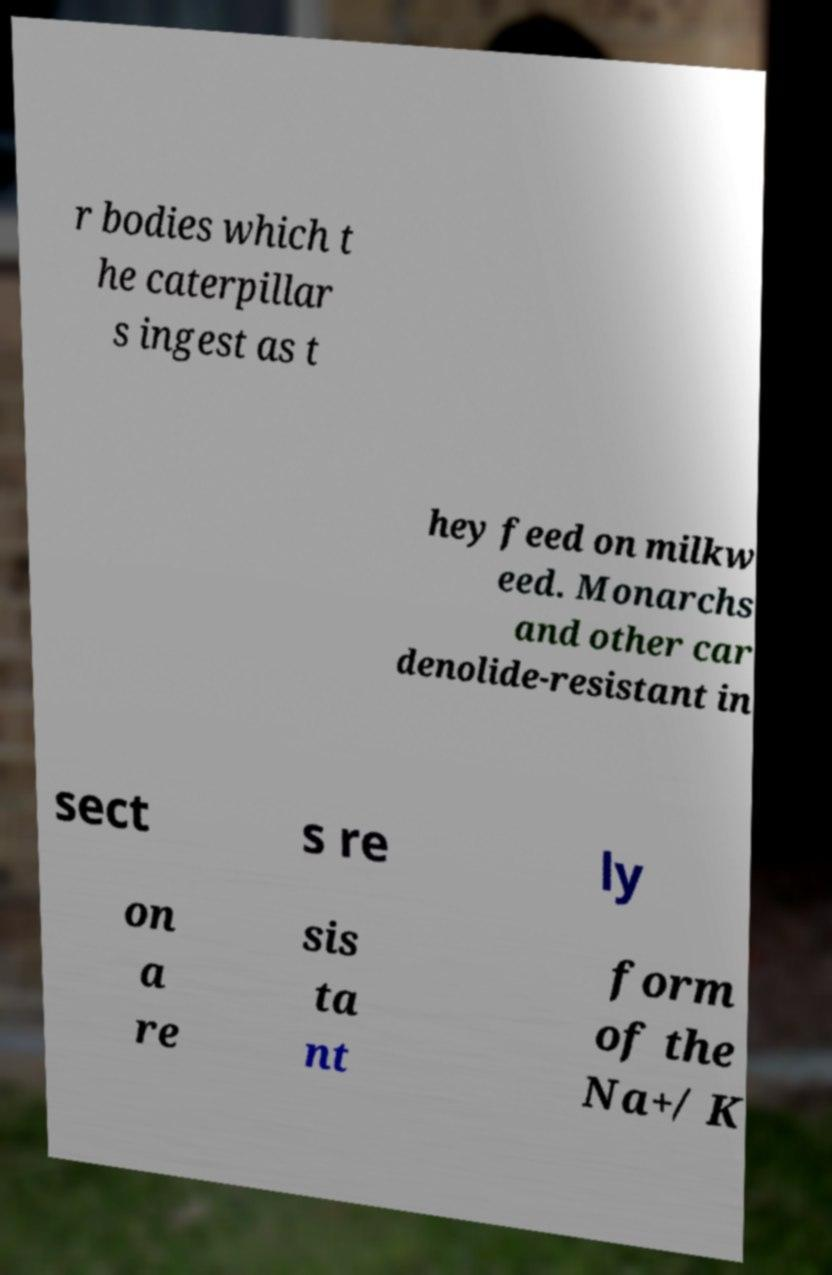Please identify and transcribe the text found in this image. r bodies which t he caterpillar s ingest as t hey feed on milkw eed. Monarchs and other car denolide-resistant in sect s re ly on a re sis ta nt form of the Na+/ K 